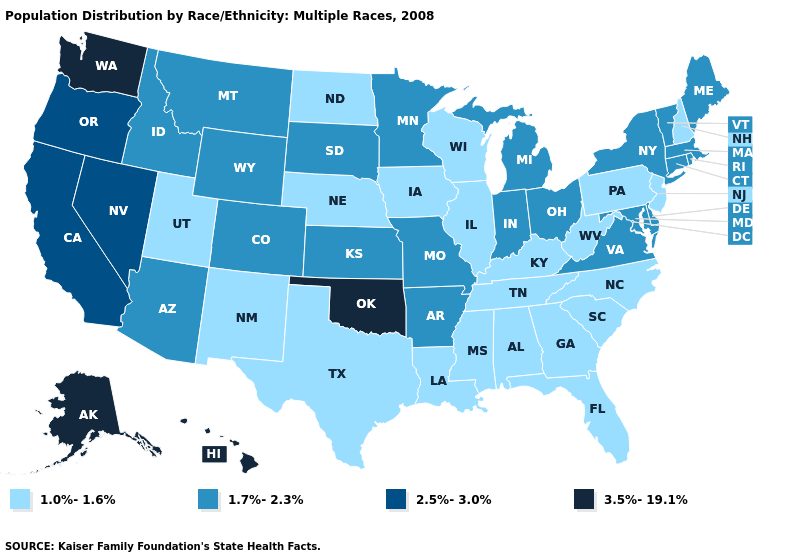Among the states that border Colorado , does New Mexico have the lowest value?
Write a very short answer. Yes. Does New Hampshire have the lowest value in the USA?
Concise answer only. Yes. What is the highest value in the West ?
Keep it brief. 3.5%-19.1%. Does Colorado have the same value as Illinois?
Quick response, please. No. What is the value of Connecticut?
Be succinct. 1.7%-2.3%. What is the highest value in states that border Rhode Island?
Give a very brief answer. 1.7%-2.3%. Which states have the highest value in the USA?
Keep it brief. Alaska, Hawaii, Oklahoma, Washington. Name the states that have a value in the range 1.0%-1.6%?
Quick response, please. Alabama, Florida, Georgia, Illinois, Iowa, Kentucky, Louisiana, Mississippi, Nebraska, New Hampshire, New Jersey, New Mexico, North Carolina, North Dakota, Pennsylvania, South Carolina, Tennessee, Texas, Utah, West Virginia, Wisconsin. What is the highest value in the Northeast ?
Be succinct. 1.7%-2.3%. Which states hav the highest value in the West?
Be succinct. Alaska, Hawaii, Washington. What is the lowest value in the MidWest?
Be succinct. 1.0%-1.6%. What is the value of Mississippi?
Short answer required. 1.0%-1.6%. What is the value of Washington?
Answer briefly. 3.5%-19.1%. Name the states that have a value in the range 2.5%-3.0%?
Write a very short answer. California, Nevada, Oregon. 